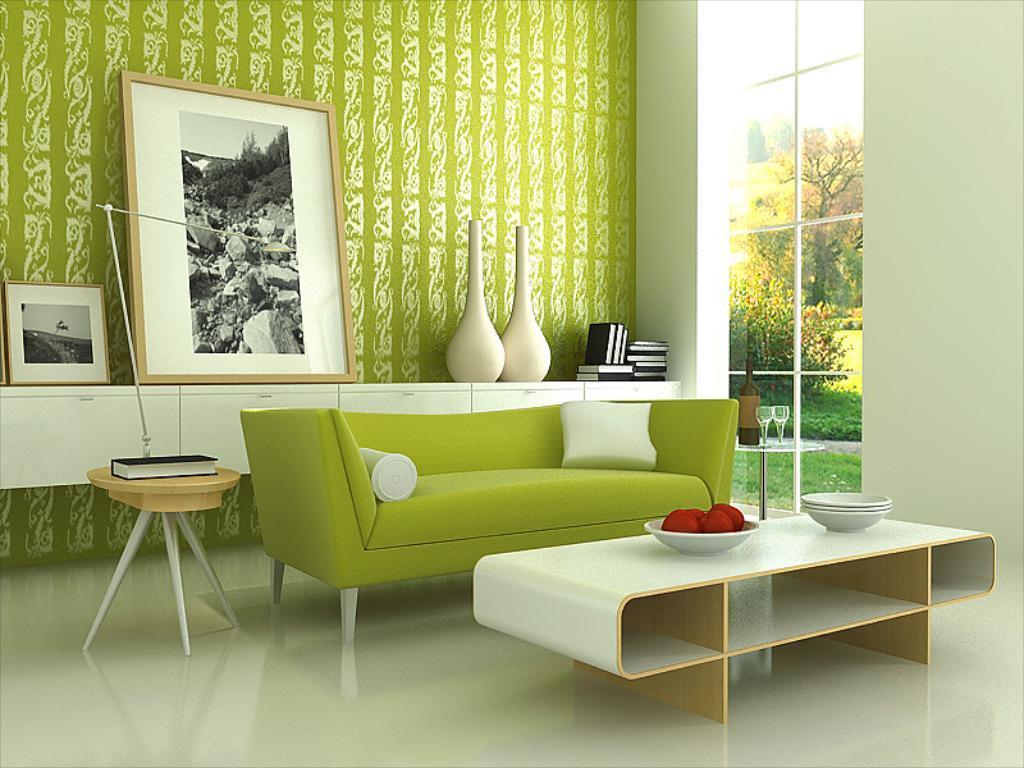Please provide a concise description of this image. Picture of a room. On this table there are pictures, vase and books. This is a couch in green color with pillow. On this table there is a bowls and fruits. On this table there is a book. The wall is in white and green color. Outside of this window we can able to see number of trees and grass. On this table there are glasses and bottle. 